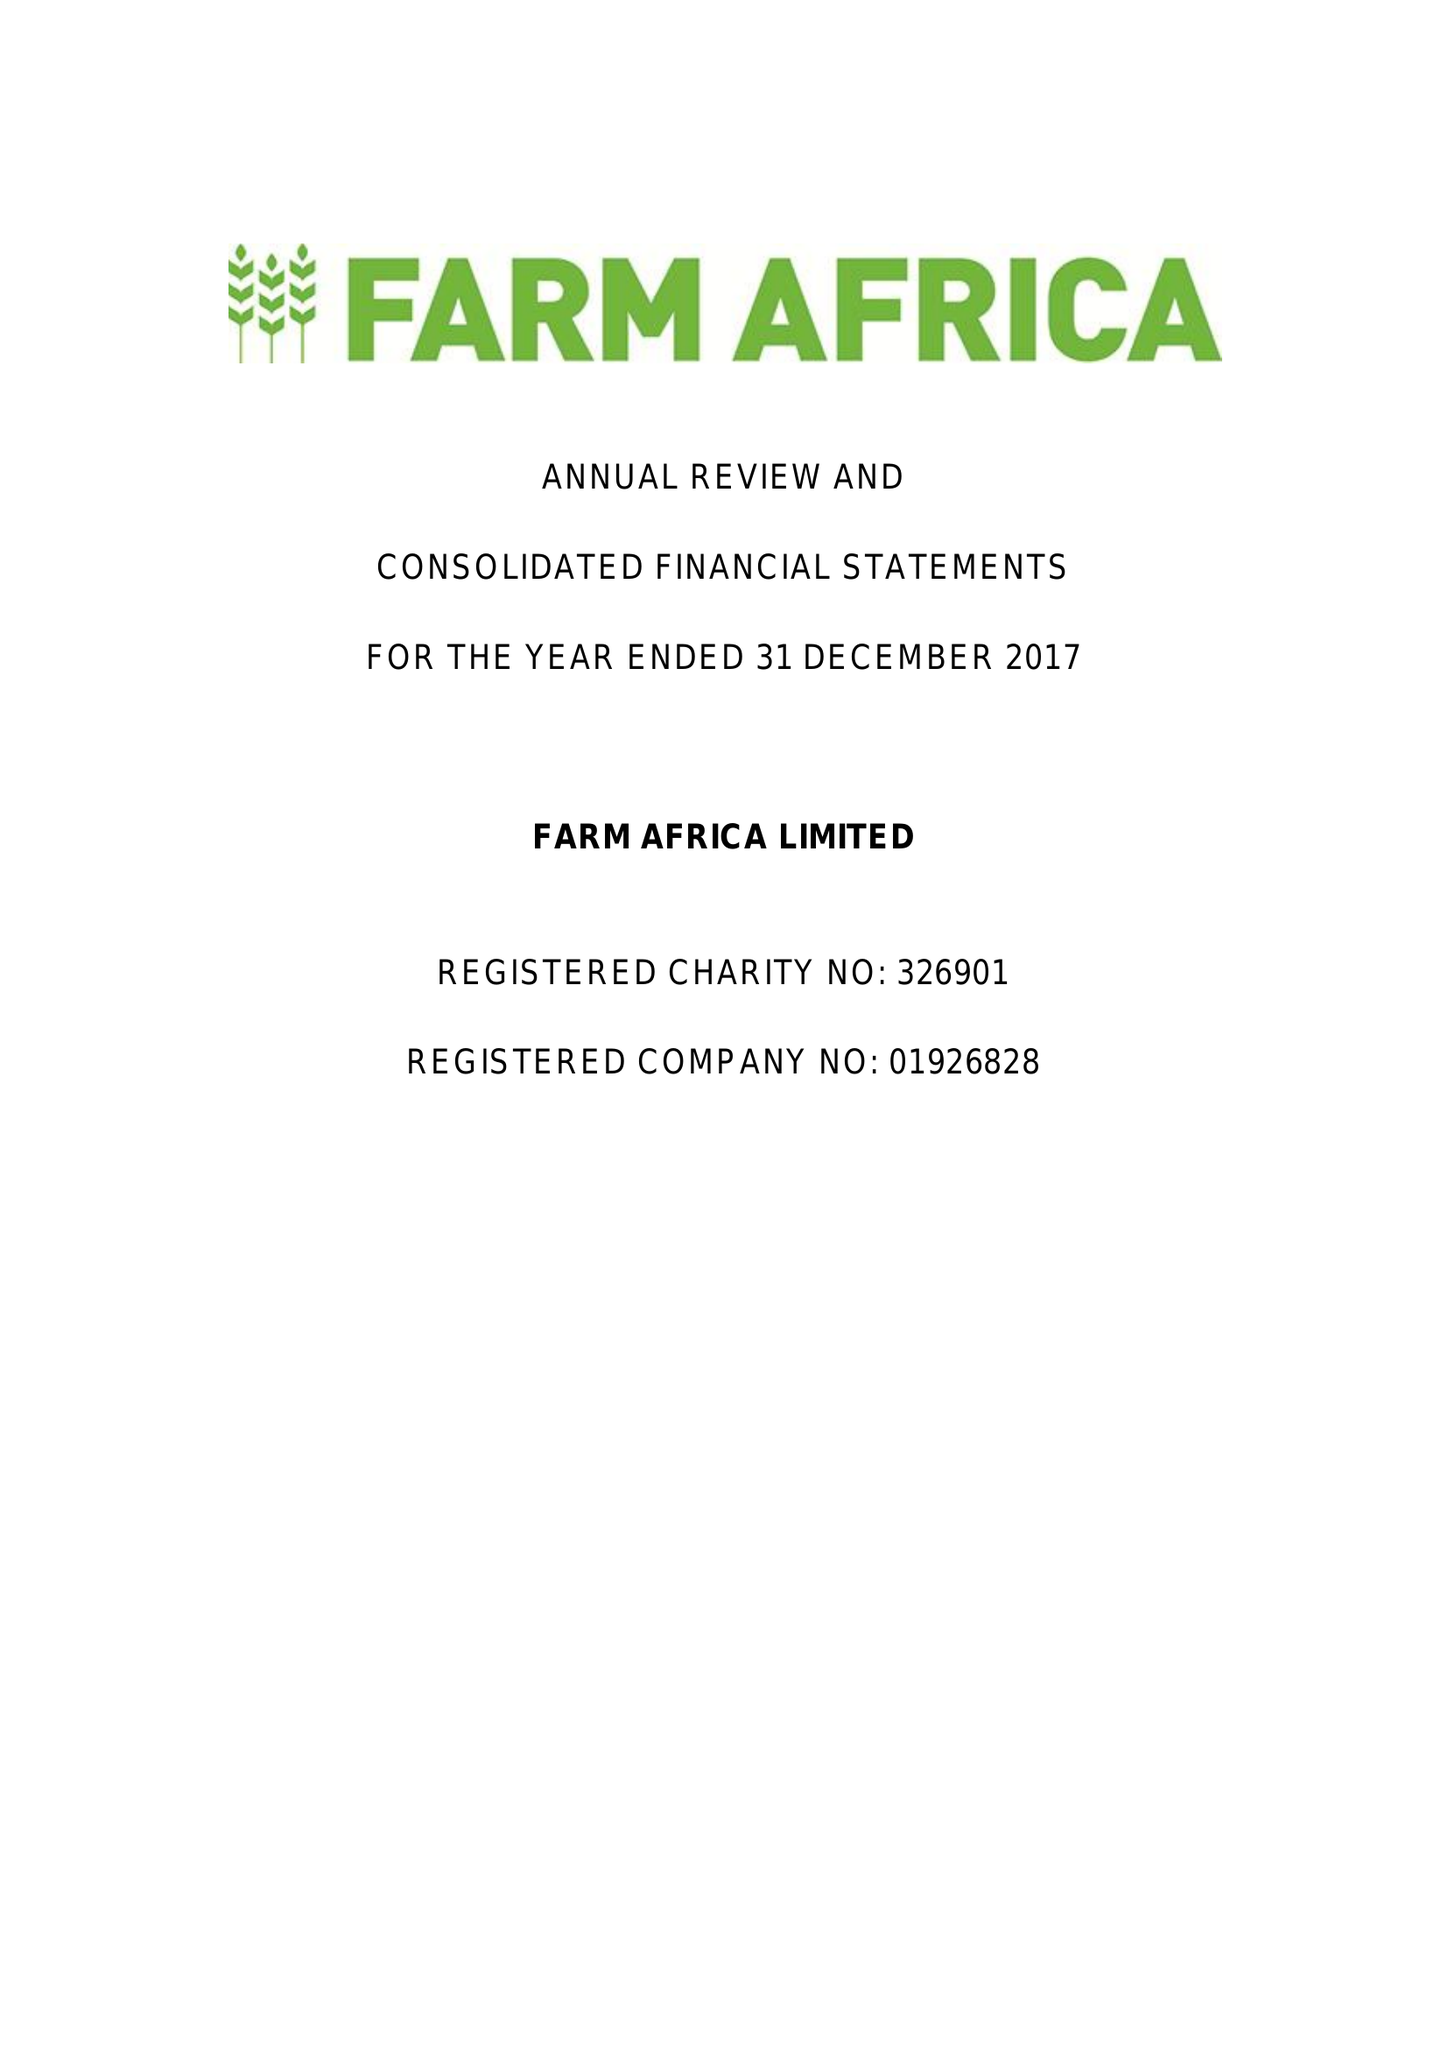What is the value for the report_date?
Answer the question using a single word or phrase. 2017-12-31 